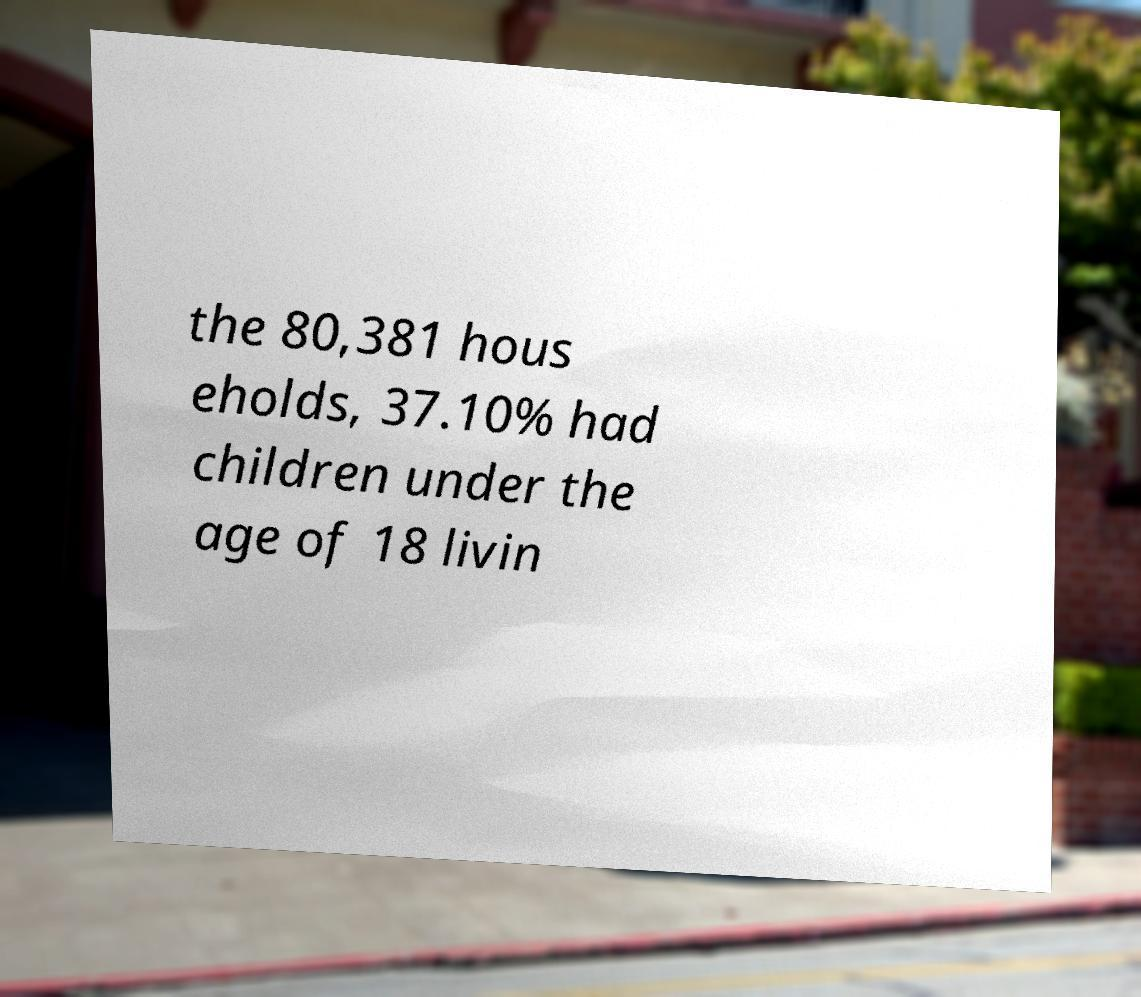Can you read and provide the text displayed in the image?This photo seems to have some interesting text. Can you extract and type it out for me? the 80,381 hous eholds, 37.10% had children under the age of 18 livin 